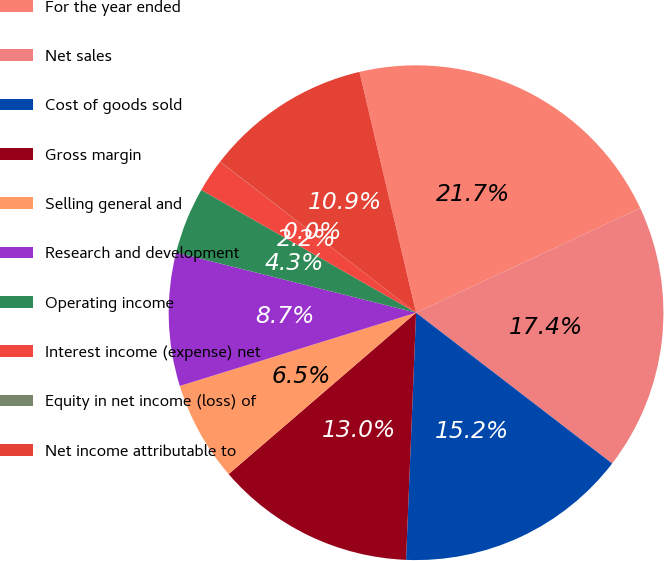Convert chart. <chart><loc_0><loc_0><loc_500><loc_500><pie_chart><fcel>For the year ended<fcel>Net sales<fcel>Cost of goods sold<fcel>Gross margin<fcel>Selling general and<fcel>Research and development<fcel>Operating income<fcel>Interest income (expense) net<fcel>Equity in net income (loss) of<fcel>Net income attributable to<nl><fcel>21.73%<fcel>17.38%<fcel>15.21%<fcel>13.04%<fcel>6.53%<fcel>8.7%<fcel>4.35%<fcel>2.18%<fcel>0.01%<fcel>10.87%<nl></chart> 